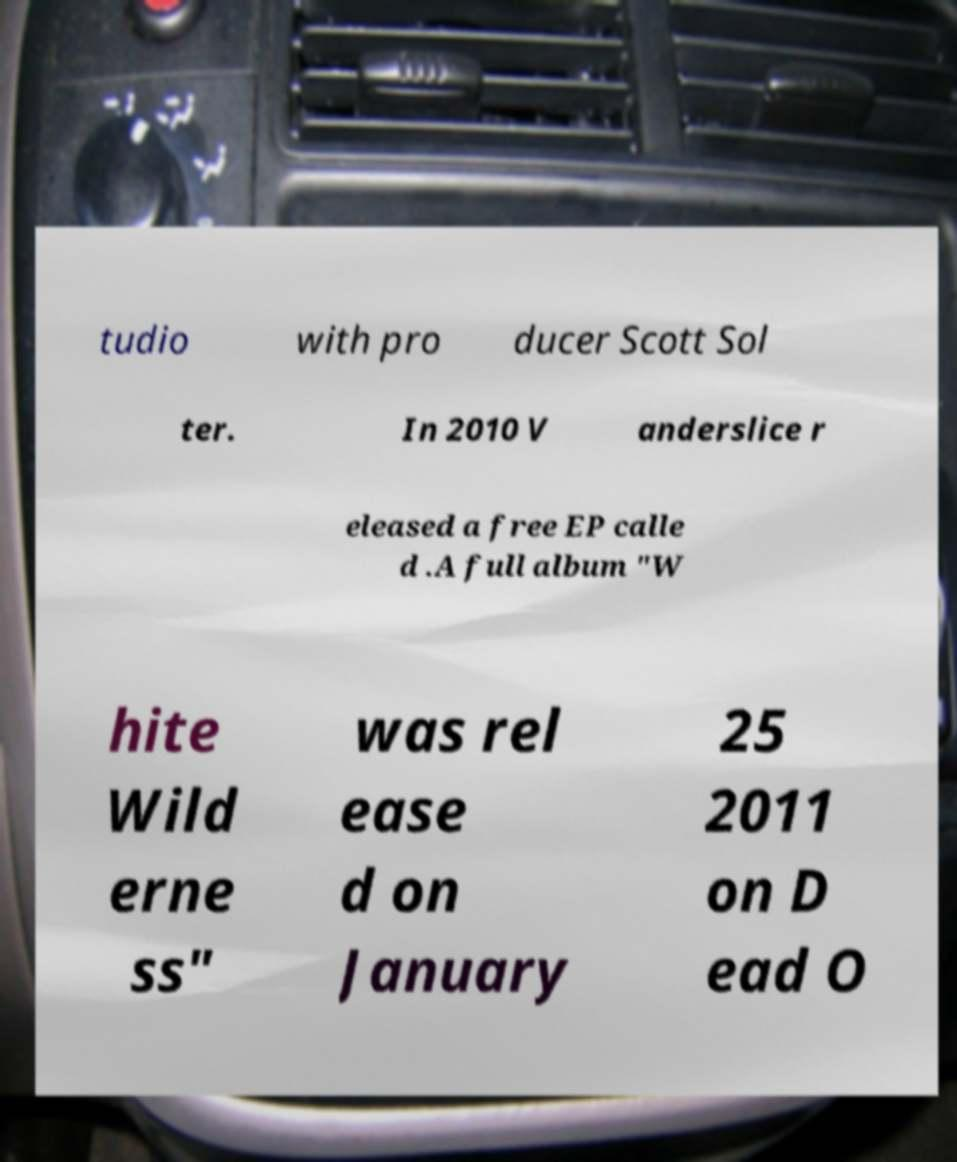Please read and relay the text visible in this image. What does it say? tudio with pro ducer Scott Sol ter. In 2010 V anderslice r eleased a free EP calle d .A full album "W hite Wild erne ss" was rel ease d on January 25 2011 on D ead O 